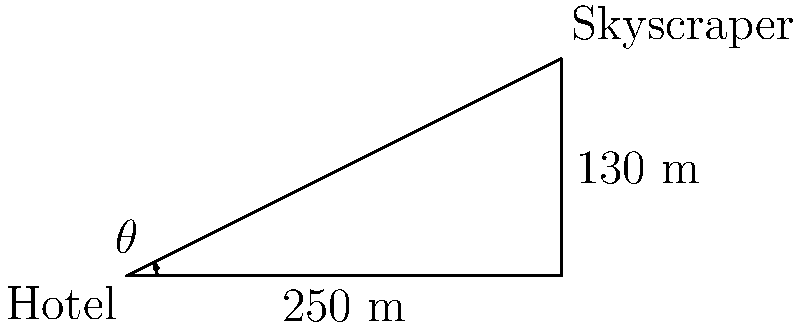From the rooftop lounge of your hotel, you observe a neighboring skyscraper. The distance between your hotel and the skyscraper is 250 meters, and the height difference between your rooftop lounge and the top floor of the skyscraper is 130 meters. What is the angle of elevation ($\theta$) from your rooftop lounge to the top floor of the skyscraper? Round your answer to the nearest degree. To solve this problem, we'll use the tangent function from trigonometry. Here's the step-by-step solution:

1) In a right triangle, tangent of an angle is the ratio of the opposite side to the adjacent side.

2) In this case:
   - The opposite side is the height difference: 130 meters
   - The adjacent side is the distance between buildings: 250 meters

3) We can express this as:

   $\tan(\theta) = \frac{\text{opposite}}{\text{adjacent}} = \frac{130}{250}$

4) To find $\theta$, we need to use the inverse tangent (arctan or $\tan^{-1}$):

   $\theta = \tan^{-1}(\frac{130}{250})$

5) Using a calculator:

   $\theta = \tan^{-1}(0.52) \approx 27.47$ degrees

6) Rounding to the nearest degree:

   $\theta \approx 27$ degrees
Answer: 27° 